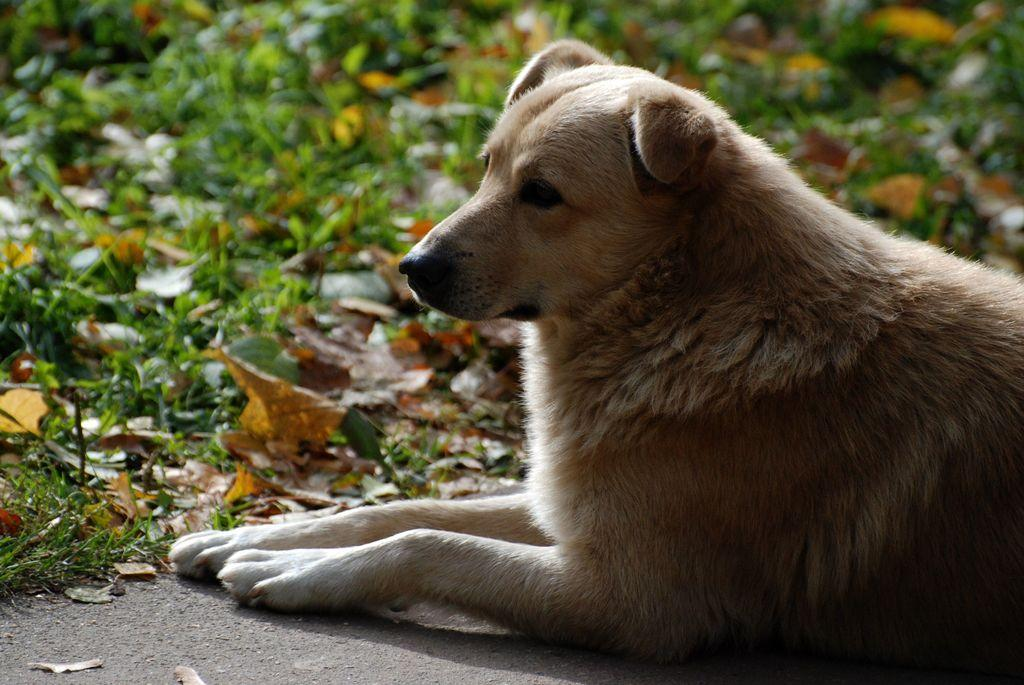What type of animal can be seen in the picture? There is a dog in the picture. What direction is the dog looking in? The dog is looking to the left side. What type of vegetation is present in the picture? There is grass in the picture. What other elements can be seen on the floor? Dry leaves and soil are visible on the floor. What type of cloth is the dog using to stretch in the picture? There is no cloth present in the picture, and the dog is not stretching. 